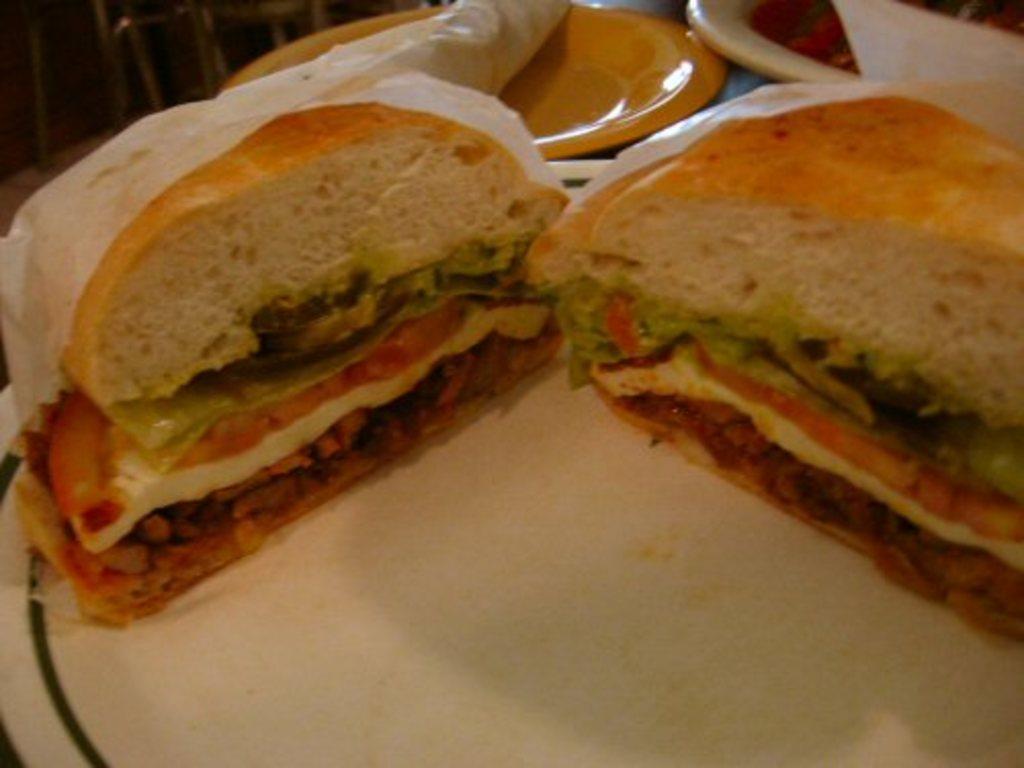Could you give a brief overview of what you see in this image? In this picture, we see two sandwiches are placed on the white plate. Beside that, we see a yellow plate and a white plate. At the top, we see some objects which look like the chairs. 